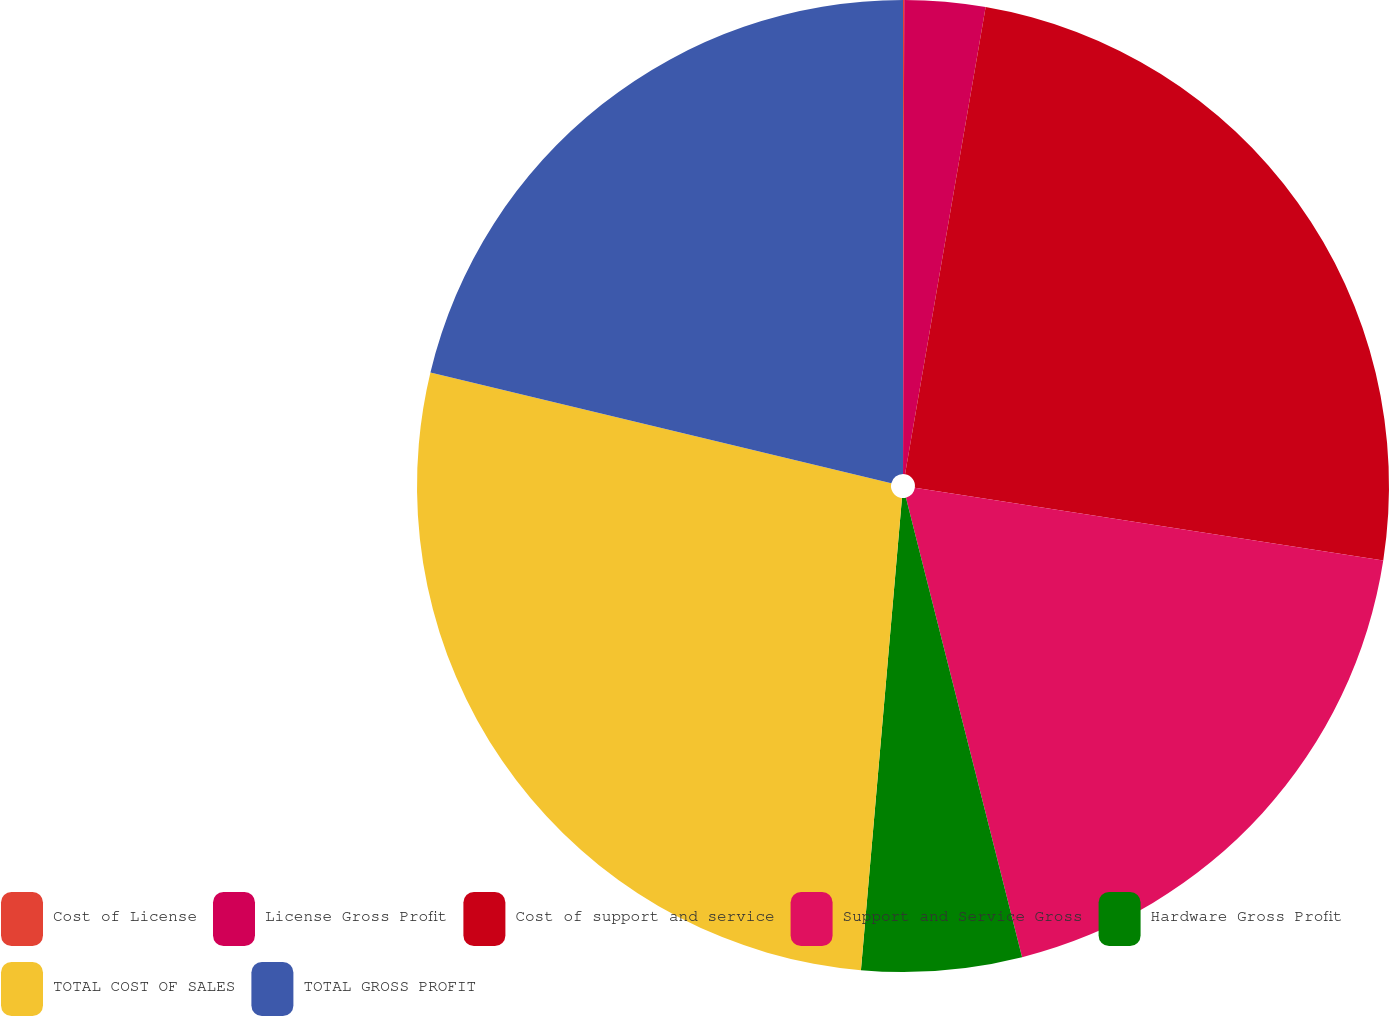<chart> <loc_0><loc_0><loc_500><loc_500><pie_chart><fcel>Cost of License<fcel>License Gross Profit<fcel>Cost of support and service<fcel>Support and Service Gross<fcel>Hardware Gross Profit<fcel>TOTAL COST OF SALES<fcel>TOTAL GROSS PROFIT<nl><fcel>0.04%<fcel>2.68%<fcel>24.73%<fcel>18.61%<fcel>5.32%<fcel>27.37%<fcel>21.25%<nl></chart> 